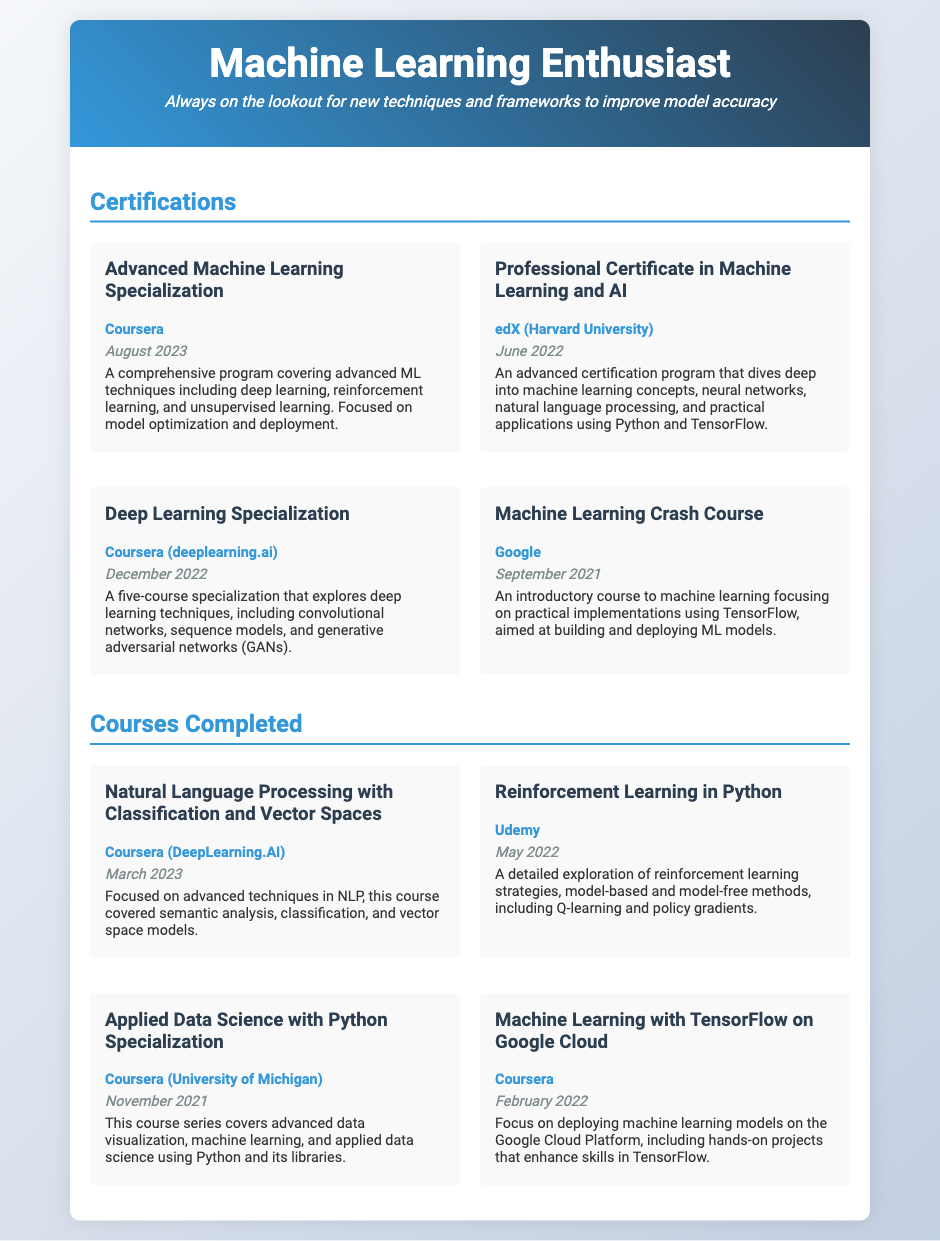What is the title of the highest-level certification completed? The highest-level certification is identified by its title in the certifications section, which is "Advanced Machine Learning Specialization."
Answer: Advanced Machine Learning Specialization Which institution issued the Professional Certificate in Machine Learning and AI? The issuer is a crucial piece of information in the certification details, listed as "edX (Harvard University)."
Answer: edX (Harvard University) What date was the Deep Learning Specialization completed? The completion date is provided for each certification, and for the Deep Learning Specialization, it states "December 2022."
Answer: December 2022 How many courses are listed under Courses Completed? The total number of courses can be counted from the document and is four in the Courses Completed section.
Answer: 4 What is the main focus of the Machine Learning Crash Course? The focus is derived from the course description which indicates it is aimed at practical implementations using TensorFlow.
Answer: Practical implementations using TensorFlow Which course was completed most recently according to the document? The courses are listed in chronological order, and the most recent course is identified as "Natural Language Processing with Classification and Vector Spaces," completed in March 2023.
Answer: Natural Language Processing with Classification and Vector Spaces What technique does the Advanced Machine Learning Specialization emphasize? The main techniques highlighted in the description of the certification include deep learning and unsupervised learning, reflecting an advanced understanding of ML.
Answer: Deep learning What course covers advanced data visualization? The specific course focused on advanced data visualization is titled "Applied Data Science with Python Specialization."
Answer: Applied Data Science with Python Specialization What are the main topics of the Reinforcement Learning in Python course? The main topics identified in the course description include reinforcement learning strategies, Q-learning, and policy gradients.
Answer: Reinforcement learning strategies 